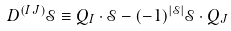Convert formula to latex. <formula><loc_0><loc_0><loc_500><loc_500>D ^ { ( I J ) } \mathcal { S } \equiv Q _ { I } \cdot \mathcal { S } - ( - 1 ) ^ { | \mathcal { S } | } \mathcal { S } \cdot Q _ { J }</formula> 